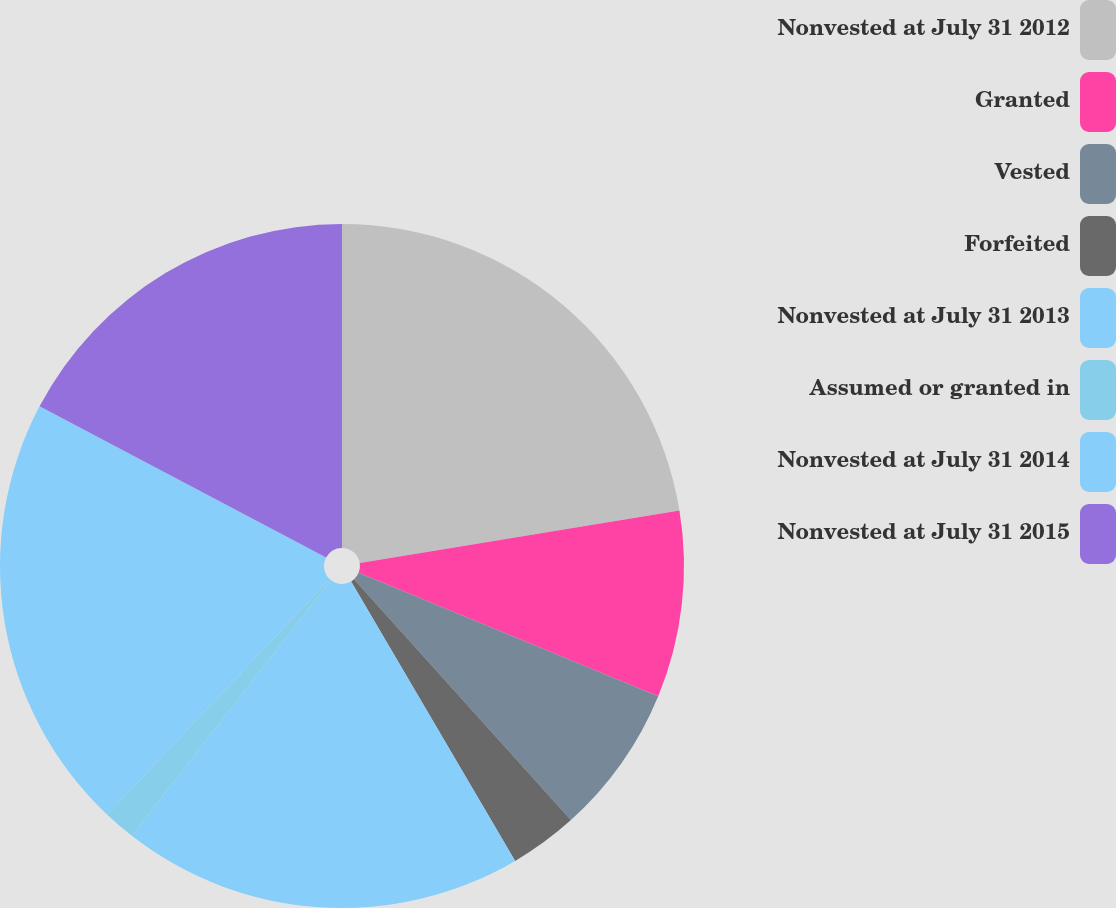Convert chart. <chart><loc_0><loc_0><loc_500><loc_500><pie_chart><fcel>Nonvested at July 31 2012<fcel>Granted<fcel>Vested<fcel>Forfeited<fcel>Nonvested at July 31 2013<fcel>Assumed or granted in<fcel>Nonvested at July 31 2014<fcel>Nonvested at July 31 2015<nl><fcel>22.4%<fcel>8.82%<fcel>7.11%<fcel>3.22%<fcel>18.98%<fcel>1.51%<fcel>20.69%<fcel>17.27%<nl></chart> 